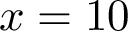<formula> <loc_0><loc_0><loc_500><loc_500>x = 1 0</formula> 